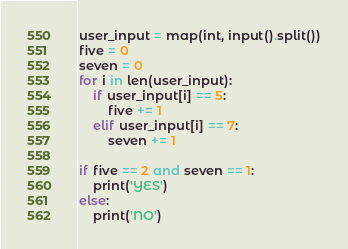<code> <loc_0><loc_0><loc_500><loc_500><_Python_>user_input = map(int, input().split())
five = 0
seven = 0
for i in len(user_input):
    if user_input[i] == 5:
        five += 1
    elif user_input[i] == 7:
        seven += 1

if five == 2 and seven == 1:
    print('YES')
else:
    print('NO')</code> 